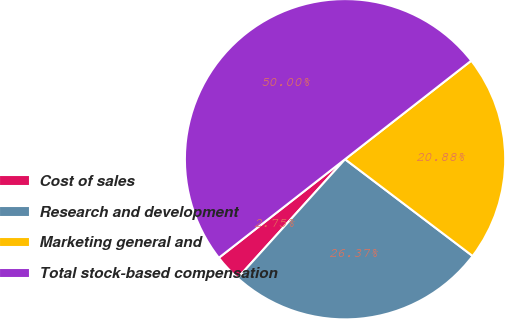Convert chart to OTSL. <chart><loc_0><loc_0><loc_500><loc_500><pie_chart><fcel>Cost of sales<fcel>Research and development<fcel>Marketing general and<fcel>Total stock-based compensation<nl><fcel>2.75%<fcel>26.37%<fcel>20.88%<fcel>50.0%<nl></chart> 